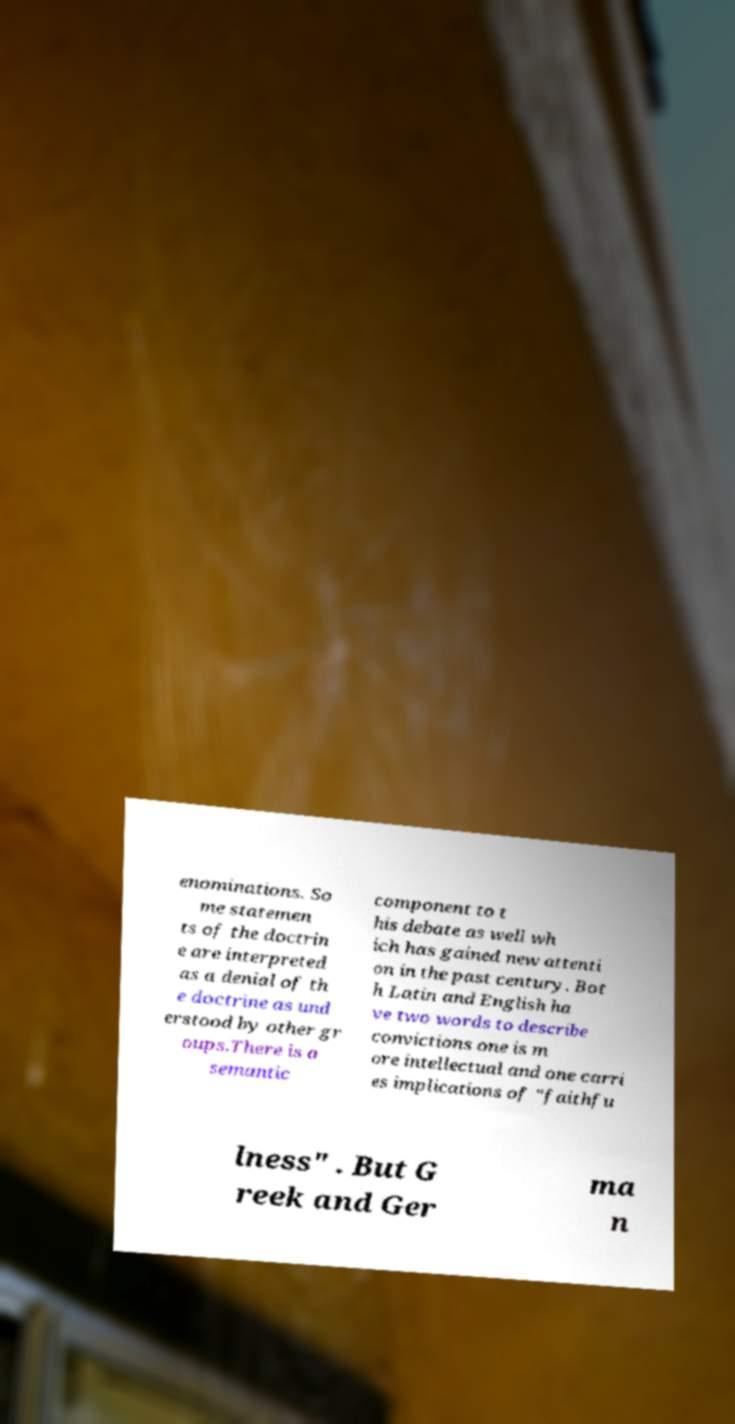What messages or text are displayed in this image? I need them in a readable, typed format. enominations. So me statemen ts of the doctrin e are interpreted as a denial of th e doctrine as und erstood by other gr oups.There is a semantic component to t his debate as well wh ich has gained new attenti on in the past century. Bot h Latin and English ha ve two words to describe convictions one is m ore intellectual and one carri es implications of "faithfu lness" . But G reek and Ger ma n 